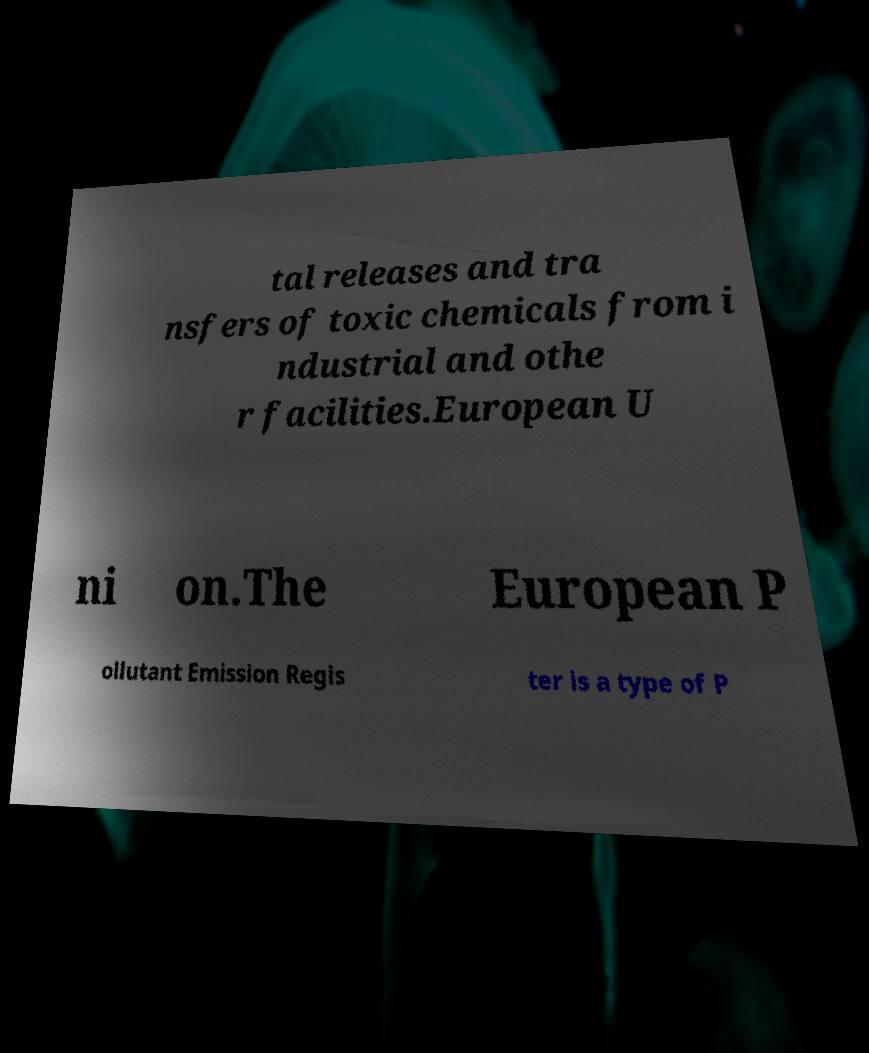For documentation purposes, I need the text within this image transcribed. Could you provide that? tal releases and tra nsfers of toxic chemicals from i ndustrial and othe r facilities.European U ni on.The European P ollutant Emission Regis ter is a type of P 